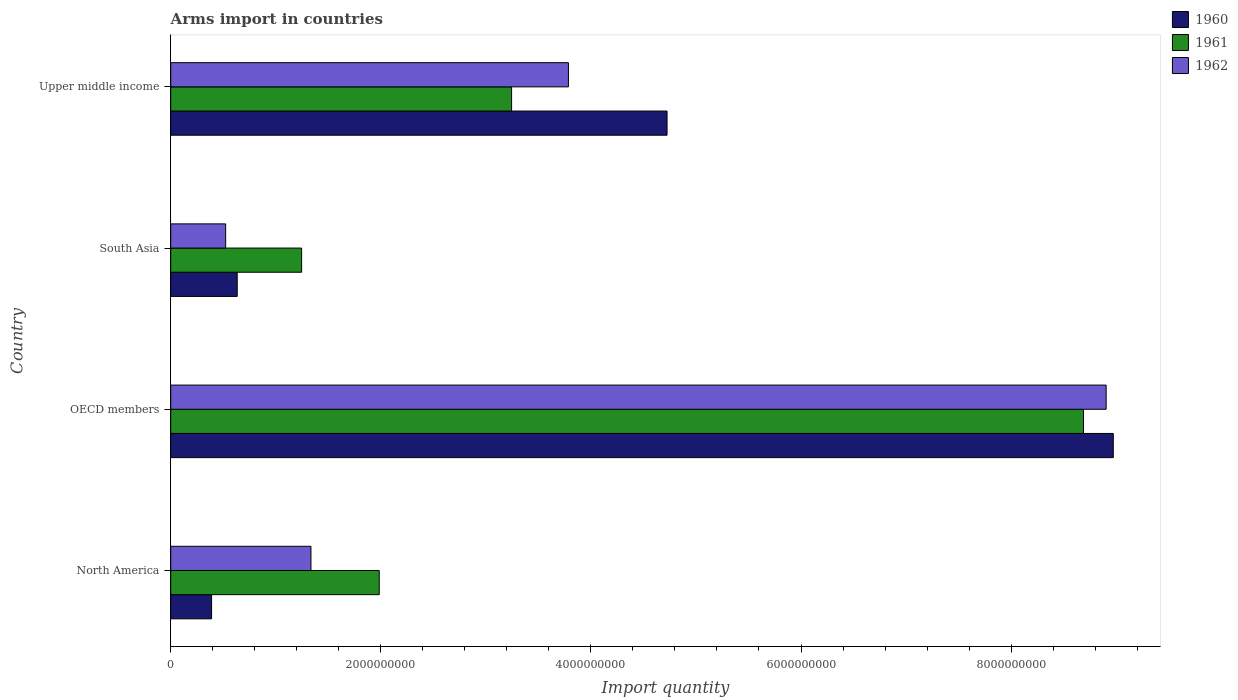Are the number of bars per tick equal to the number of legend labels?
Give a very brief answer. Yes. Are the number of bars on each tick of the Y-axis equal?
Your answer should be compact. Yes. How many bars are there on the 1st tick from the top?
Offer a very short reply. 3. What is the label of the 1st group of bars from the top?
Your response must be concise. Upper middle income. What is the total arms import in 1961 in OECD members?
Provide a short and direct response. 8.69e+09. Across all countries, what is the maximum total arms import in 1962?
Your answer should be very brief. 8.90e+09. Across all countries, what is the minimum total arms import in 1960?
Your answer should be very brief. 3.89e+08. What is the total total arms import in 1960 in the graph?
Provide a succinct answer. 1.47e+1. What is the difference between the total arms import in 1960 in OECD members and that in Upper middle income?
Offer a terse response. 4.25e+09. What is the difference between the total arms import in 1960 in Upper middle income and the total arms import in 1961 in South Asia?
Offer a terse response. 3.48e+09. What is the average total arms import in 1961 per country?
Provide a short and direct response. 3.79e+09. What is the difference between the total arms import in 1961 and total arms import in 1962 in North America?
Keep it short and to the point. 6.50e+08. In how many countries, is the total arms import in 1962 greater than 4800000000 ?
Your answer should be very brief. 1. What is the ratio of the total arms import in 1962 in South Asia to that in Upper middle income?
Your answer should be very brief. 0.14. What is the difference between the highest and the second highest total arms import in 1960?
Provide a succinct answer. 4.25e+09. What is the difference between the highest and the lowest total arms import in 1962?
Your answer should be compact. 8.38e+09. Where does the legend appear in the graph?
Make the answer very short. Top right. How many legend labels are there?
Provide a short and direct response. 3. What is the title of the graph?
Offer a very short reply. Arms import in countries. Does "1982" appear as one of the legend labels in the graph?
Give a very brief answer. No. What is the label or title of the X-axis?
Provide a succinct answer. Import quantity. What is the label or title of the Y-axis?
Provide a short and direct response. Country. What is the Import quantity in 1960 in North America?
Keep it short and to the point. 3.89e+08. What is the Import quantity of 1961 in North America?
Make the answer very short. 1.98e+09. What is the Import quantity of 1962 in North America?
Your answer should be very brief. 1.34e+09. What is the Import quantity in 1960 in OECD members?
Ensure brevity in your answer.  8.97e+09. What is the Import quantity in 1961 in OECD members?
Your answer should be compact. 8.69e+09. What is the Import quantity in 1962 in OECD members?
Keep it short and to the point. 8.90e+09. What is the Import quantity of 1960 in South Asia?
Offer a terse response. 6.33e+08. What is the Import quantity in 1961 in South Asia?
Provide a succinct answer. 1.25e+09. What is the Import quantity in 1962 in South Asia?
Your response must be concise. 5.23e+08. What is the Import quantity in 1960 in Upper middle income?
Your answer should be very brief. 4.72e+09. What is the Import quantity of 1961 in Upper middle income?
Make the answer very short. 3.24e+09. What is the Import quantity in 1962 in Upper middle income?
Keep it short and to the point. 3.79e+09. Across all countries, what is the maximum Import quantity in 1960?
Your answer should be very brief. 8.97e+09. Across all countries, what is the maximum Import quantity in 1961?
Give a very brief answer. 8.69e+09. Across all countries, what is the maximum Import quantity in 1962?
Give a very brief answer. 8.90e+09. Across all countries, what is the minimum Import quantity of 1960?
Offer a terse response. 3.89e+08. Across all countries, what is the minimum Import quantity of 1961?
Provide a short and direct response. 1.25e+09. Across all countries, what is the minimum Import quantity of 1962?
Give a very brief answer. 5.23e+08. What is the total Import quantity in 1960 in the graph?
Offer a terse response. 1.47e+1. What is the total Import quantity in 1961 in the graph?
Provide a succinct answer. 1.52e+1. What is the total Import quantity in 1962 in the graph?
Your response must be concise. 1.45e+1. What is the difference between the Import quantity of 1960 in North America and that in OECD members?
Provide a succinct answer. -8.58e+09. What is the difference between the Import quantity in 1961 in North America and that in OECD members?
Provide a succinct answer. -6.70e+09. What is the difference between the Import quantity in 1962 in North America and that in OECD members?
Make the answer very short. -7.57e+09. What is the difference between the Import quantity in 1960 in North America and that in South Asia?
Your answer should be very brief. -2.44e+08. What is the difference between the Import quantity of 1961 in North America and that in South Asia?
Provide a succinct answer. 7.39e+08. What is the difference between the Import quantity in 1962 in North America and that in South Asia?
Provide a succinct answer. 8.12e+08. What is the difference between the Import quantity of 1960 in North America and that in Upper middle income?
Your answer should be compact. -4.34e+09. What is the difference between the Import quantity in 1961 in North America and that in Upper middle income?
Keep it short and to the point. -1.26e+09. What is the difference between the Import quantity in 1962 in North America and that in Upper middle income?
Offer a very short reply. -2.45e+09. What is the difference between the Import quantity in 1960 in OECD members and that in South Asia?
Your answer should be very brief. 8.34e+09. What is the difference between the Import quantity of 1961 in OECD members and that in South Asia?
Provide a succinct answer. 7.44e+09. What is the difference between the Import quantity in 1962 in OECD members and that in South Asia?
Keep it short and to the point. 8.38e+09. What is the difference between the Import quantity of 1960 in OECD members and that in Upper middle income?
Your answer should be very brief. 4.25e+09. What is the difference between the Import quantity of 1961 in OECD members and that in Upper middle income?
Give a very brief answer. 5.44e+09. What is the difference between the Import quantity in 1962 in OECD members and that in Upper middle income?
Your response must be concise. 5.12e+09. What is the difference between the Import quantity of 1960 in South Asia and that in Upper middle income?
Offer a very short reply. -4.09e+09. What is the difference between the Import quantity in 1961 in South Asia and that in Upper middle income?
Give a very brief answer. -2.00e+09. What is the difference between the Import quantity of 1962 in South Asia and that in Upper middle income?
Your answer should be compact. -3.26e+09. What is the difference between the Import quantity in 1960 in North America and the Import quantity in 1961 in OECD members?
Keep it short and to the point. -8.30e+09. What is the difference between the Import quantity in 1960 in North America and the Import quantity in 1962 in OECD members?
Offer a terse response. -8.52e+09. What is the difference between the Import quantity in 1961 in North America and the Import quantity in 1962 in OECD members?
Your answer should be compact. -6.92e+09. What is the difference between the Import quantity of 1960 in North America and the Import quantity of 1961 in South Asia?
Your response must be concise. -8.57e+08. What is the difference between the Import quantity of 1960 in North America and the Import quantity of 1962 in South Asia?
Provide a succinct answer. -1.34e+08. What is the difference between the Import quantity in 1961 in North America and the Import quantity in 1962 in South Asia?
Offer a terse response. 1.46e+09. What is the difference between the Import quantity of 1960 in North America and the Import quantity of 1961 in Upper middle income?
Your answer should be very brief. -2.86e+09. What is the difference between the Import quantity of 1960 in North America and the Import quantity of 1962 in Upper middle income?
Offer a very short reply. -3.40e+09. What is the difference between the Import quantity in 1961 in North America and the Import quantity in 1962 in Upper middle income?
Provide a short and direct response. -1.80e+09. What is the difference between the Import quantity in 1960 in OECD members and the Import quantity in 1961 in South Asia?
Provide a succinct answer. 7.73e+09. What is the difference between the Import quantity in 1960 in OECD members and the Import quantity in 1962 in South Asia?
Provide a succinct answer. 8.45e+09. What is the difference between the Import quantity in 1961 in OECD members and the Import quantity in 1962 in South Asia?
Make the answer very short. 8.17e+09. What is the difference between the Import quantity in 1960 in OECD members and the Import quantity in 1961 in Upper middle income?
Ensure brevity in your answer.  5.73e+09. What is the difference between the Import quantity of 1960 in OECD members and the Import quantity of 1962 in Upper middle income?
Offer a very short reply. 5.19e+09. What is the difference between the Import quantity in 1961 in OECD members and the Import quantity in 1962 in Upper middle income?
Give a very brief answer. 4.90e+09. What is the difference between the Import quantity in 1960 in South Asia and the Import quantity in 1961 in Upper middle income?
Your answer should be compact. -2.61e+09. What is the difference between the Import quantity of 1960 in South Asia and the Import quantity of 1962 in Upper middle income?
Ensure brevity in your answer.  -3.15e+09. What is the difference between the Import quantity in 1961 in South Asia and the Import quantity in 1962 in Upper middle income?
Keep it short and to the point. -2.54e+09. What is the average Import quantity of 1960 per country?
Give a very brief answer. 3.68e+09. What is the average Import quantity in 1961 per country?
Provide a succinct answer. 3.79e+09. What is the average Import quantity in 1962 per country?
Keep it short and to the point. 3.64e+09. What is the difference between the Import quantity of 1960 and Import quantity of 1961 in North America?
Provide a succinct answer. -1.60e+09. What is the difference between the Import quantity in 1960 and Import quantity in 1962 in North America?
Give a very brief answer. -9.46e+08. What is the difference between the Import quantity of 1961 and Import quantity of 1962 in North America?
Your response must be concise. 6.50e+08. What is the difference between the Import quantity in 1960 and Import quantity in 1961 in OECD members?
Your response must be concise. 2.84e+08. What is the difference between the Import quantity of 1960 and Import quantity of 1962 in OECD members?
Ensure brevity in your answer.  6.80e+07. What is the difference between the Import quantity of 1961 and Import quantity of 1962 in OECD members?
Make the answer very short. -2.16e+08. What is the difference between the Import quantity of 1960 and Import quantity of 1961 in South Asia?
Keep it short and to the point. -6.13e+08. What is the difference between the Import quantity in 1960 and Import quantity in 1962 in South Asia?
Offer a very short reply. 1.10e+08. What is the difference between the Import quantity of 1961 and Import quantity of 1962 in South Asia?
Make the answer very short. 7.23e+08. What is the difference between the Import quantity of 1960 and Import quantity of 1961 in Upper middle income?
Offer a terse response. 1.48e+09. What is the difference between the Import quantity in 1960 and Import quantity in 1962 in Upper middle income?
Provide a succinct answer. 9.39e+08. What is the difference between the Import quantity of 1961 and Import quantity of 1962 in Upper middle income?
Offer a very short reply. -5.41e+08. What is the ratio of the Import quantity of 1960 in North America to that in OECD members?
Ensure brevity in your answer.  0.04. What is the ratio of the Import quantity of 1961 in North America to that in OECD members?
Give a very brief answer. 0.23. What is the ratio of the Import quantity in 1962 in North America to that in OECD members?
Provide a succinct answer. 0.15. What is the ratio of the Import quantity of 1960 in North America to that in South Asia?
Give a very brief answer. 0.61. What is the ratio of the Import quantity of 1961 in North America to that in South Asia?
Ensure brevity in your answer.  1.59. What is the ratio of the Import quantity in 1962 in North America to that in South Asia?
Your answer should be very brief. 2.55. What is the ratio of the Import quantity in 1960 in North America to that in Upper middle income?
Your answer should be compact. 0.08. What is the ratio of the Import quantity of 1961 in North America to that in Upper middle income?
Ensure brevity in your answer.  0.61. What is the ratio of the Import quantity in 1962 in North America to that in Upper middle income?
Make the answer very short. 0.35. What is the ratio of the Import quantity of 1960 in OECD members to that in South Asia?
Ensure brevity in your answer.  14.18. What is the ratio of the Import quantity of 1961 in OECD members to that in South Asia?
Give a very brief answer. 6.97. What is the ratio of the Import quantity in 1962 in OECD members to that in South Asia?
Your response must be concise. 17.03. What is the ratio of the Import quantity in 1960 in OECD members to that in Upper middle income?
Offer a terse response. 1.9. What is the ratio of the Import quantity in 1961 in OECD members to that in Upper middle income?
Provide a short and direct response. 2.68. What is the ratio of the Import quantity in 1962 in OECD members to that in Upper middle income?
Provide a short and direct response. 2.35. What is the ratio of the Import quantity in 1960 in South Asia to that in Upper middle income?
Provide a succinct answer. 0.13. What is the ratio of the Import quantity in 1961 in South Asia to that in Upper middle income?
Offer a terse response. 0.38. What is the ratio of the Import quantity of 1962 in South Asia to that in Upper middle income?
Give a very brief answer. 0.14. What is the difference between the highest and the second highest Import quantity of 1960?
Offer a terse response. 4.25e+09. What is the difference between the highest and the second highest Import quantity in 1961?
Your answer should be very brief. 5.44e+09. What is the difference between the highest and the second highest Import quantity of 1962?
Give a very brief answer. 5.12e+09. What is the difference between the highest and the lowest Import quantity in 1960?
Keep it short and to the point. 8.58e+09. What is the difference between the highest and the lowest Import quantity of 1961?
Your answer should be very brief. 7.44e+09. What is the difference between the highest and the lowest Import quantity in 1962?
Give a very brief answer. 8.38e+09. 